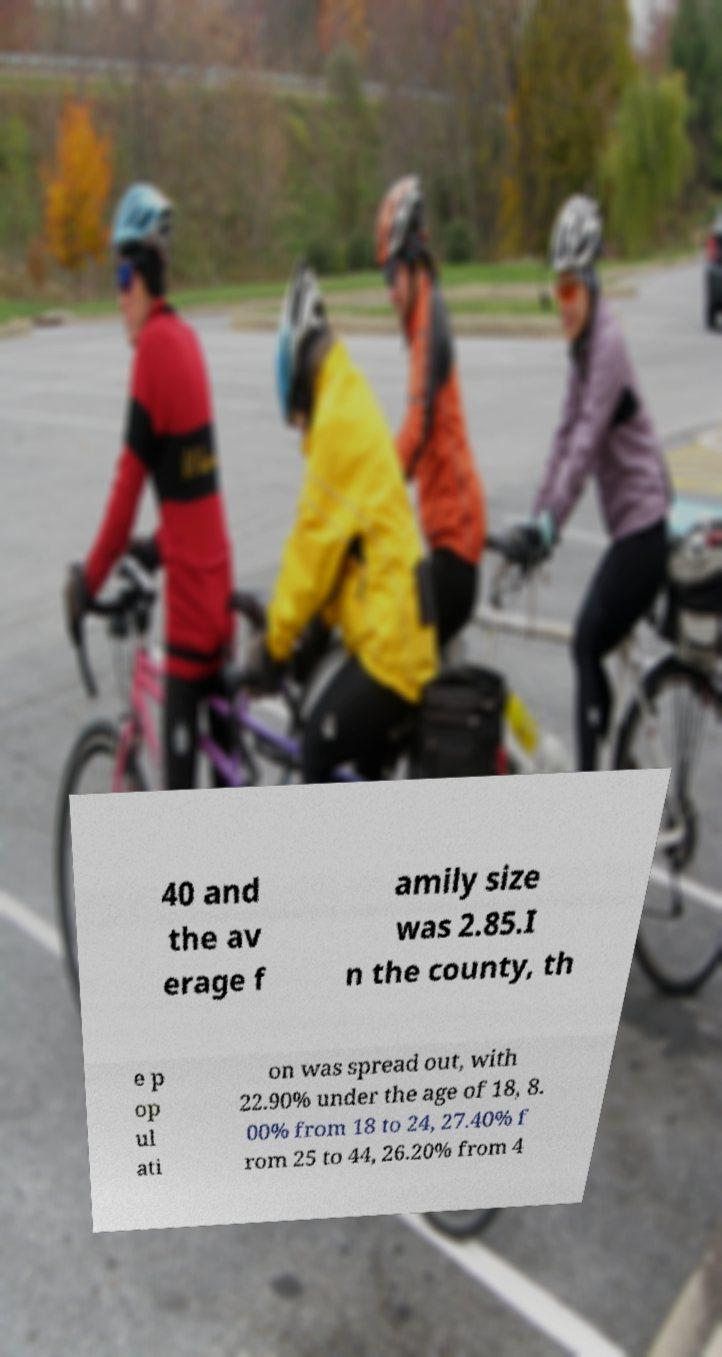Please identify and transcribe the text found in this image. 40 and the av erage f amily size was 2.85.I n the county, th e p op ul ati on was spread out, with 22.90% under the age of 18, 8. 00% from 18 to 24, 27.40% f rom 25 to 44, 26.20% from 4 